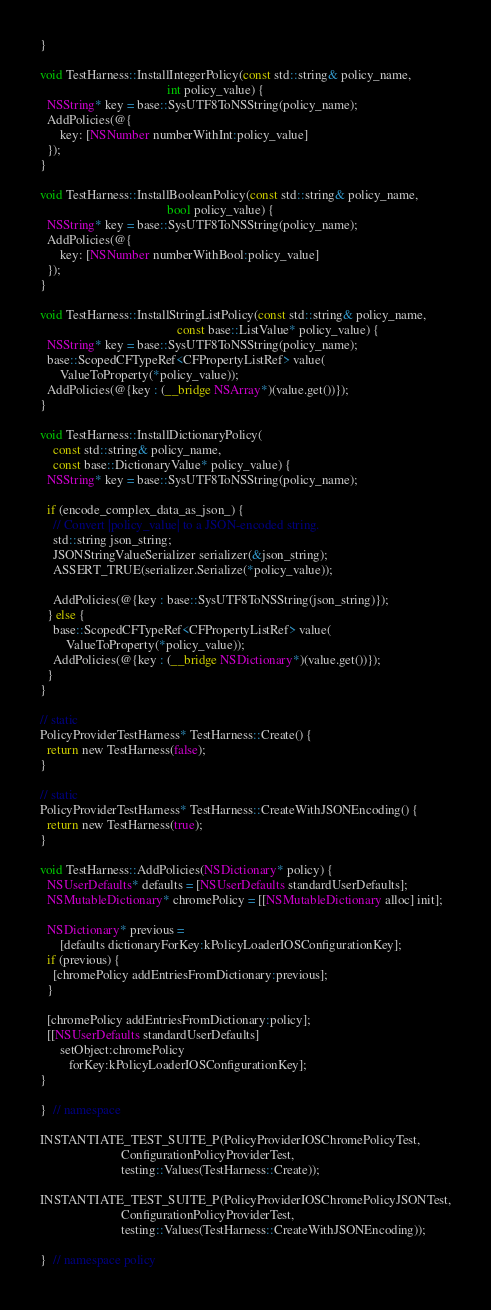<code> <loc_0><loc_0><loc_500><loc_500><_ObjectiveC_>}

void TestHarness::InstallIntegerPolicy(const std::string& policy_name,
                                       int policy_value) {
  NSString* key = base::SysUTF8ToNSString(policy_name);
  AddPolicies(@{
      key: [NSNumber numberWithInt:policy_value]
  });
}

void TestHarness::InstallBooleanPolicy(const std::string& policy_name,
                                       bool policy_value) {
  NSString* key = base::SysUTF8ToNSString(policy_name);
  AddPolicies(@{
      key: [NSNumber numberWithBool:policy_value]
  });
}

void TestHarness::InstallStringListPolicy(const std::string& policy_name,
                                          const base::ListValue* policy_value) {
  NSString* key = base::SysUTF8ToNSString(policy_name);
  base::ScopedCFTypeRef<CFPropertyListRef> value(
      ValueToProperty(*policy_value));
  AddPolicies(@{key : (__bridge NSArray*)(value.get())});
}

void TestHarness::InstallDictionaryPolicy(
    const std::string& policy_name,
    const base::DictionaryValue* policy_value) {
  NSString* key = base::SysUTF8ToNSString(policy_name);

  if (encode_complex_data_as_json_) {
    // Convert |policy_value| to a JSON-encoded string.
    std::string json_string;
    JSONStringValueSerializer serializer(&json_string);
    ASSERT_TRUE(serializer.Serialize(*policy_value));

    AddPolicies(@{key : base::SysUTF8ToNSString(json_string)});
  } else {
    base::ScopedCFTypeRef<CFPropertyListRef> value(
        ValueToProperty(*policy_value));
    AddPolicies(@{key : (__bridge NSDictionary*)(value.get())});
  }
}

// static
PolicyProviderTestHarness* TestHarness::Create() {
  return new TestHarness(false);
}

// static
PolicyProviderTestHarness* TestHarness::CreateWithJSONEncoding() {
  return new TestHarness(true);
}

void TestHarness::AddPolicies(NSDictionary* policy) {
  NSUserDefaults* defaults = [NSUserDefaults standardUserDefaults];
  NSMutableDictionary* chromePolicy = [[NSMutableDictionary alloc] init];

  NSDictionary* previous =
      [defaults dictionaryForKey:kPolicyLoaderIOSConfigurationKey];
  if (previous) {
    [chromePolicy addEntriesFromDictionary:previous];
  }

  [chromePolicy addEntriesFromDictionary:policy];
  [[NSUserDefaults standardUserDefaults]
      setObject:chromePolicy
         forKey:kPolicyLoaderIOSConfigurationKey];
}

}  // namespace

INSTANTIATE_TEST_SUITE_P(PolicyProviderIOSChromePolicyTest,
                         ConfigurationPolicyProviderTest,
                         testing::Values(TestHarness::Create));

INSTANTIATE_TEST_SUITE_P(PolicyProviderIOSChromePolicyJSONTest,
                         ConfigurationPolicyProviderTest,
                         testing::Values(TestHarness::CreateWithJSONEncoding));

}  // namespace policy
</code> 